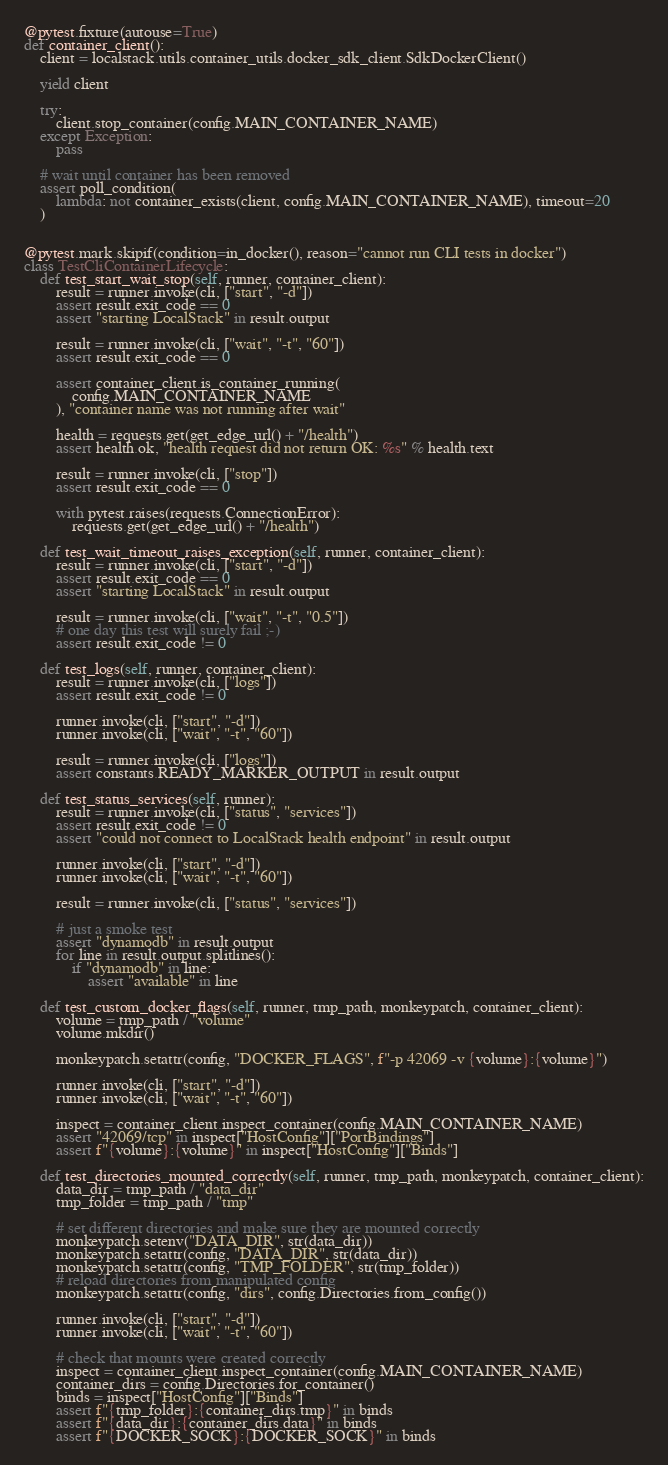Convert code to text. <code><loc_0><loc_0><loc_500><loc_500><_Python_>

@pytest.fixture(autouse=True)
def container_client():
    client = localstack.utils.container_utils.docker_sdk_client.SdkDockerClient()

    yield client

    try:
        client.stop_container(config.MAIN_CONTAINER_NAME)
    except Exception:
        pass

    # wait until container has been removed
    assert poll_condition(
        lambda: not container_exists(client, config.MAIN_CONTAINER_NAME), timeout=20
    )


@pytest.mark.skipif(condition=in_docker(), reason="cannot run CLI tests in docker")
class TestCliContainerLifecycle:
    def test_start_wait_stop(self, runner, container_client):
        result = runner.invoke(cli, ["start", "-d"])
        assert result.exit_code == 0
        assert "starting LocalStack" in result.output

        result = runner.invoke(cli, ["wait", "-t", "60"])
        assert result.exit_code == 0

        assert container_client.is_container_running(
            config.MAIN_CONTAINER_NAME
        ), "container name was not running after wait"

        health = requests.get(get_edge_url() + "/health")
        assert health.ok, "health request did not return OK: %s" % health.text

        result = runner.invoke(cli, ["stop"])
        assert result.exit_code == 0

        with pytest.raises(requests.ConnectionError):
            requests.get(get_edge_url() + "/health")

    def test_wait_timeout_raises_exception(self, runner, container_client):
        result = runner.invoke(cli, ["start", "-d"])
        assert result.exit_code == 0
        assert "starting LocalStack" in result.output

        result = runner.invoke(cli, ["wait", "-t", "0.5"])
        # one day this test will surely fail ;-)
        assert result.exit_code != 0

    def test_logs(self, runner, container_client):
        result = runner.invoke(cli, ["logs"])
        assert result.exit_code != 0

        runner.invoke(cli, ["start", "-d"])
        runner.invoke(cli, ["wait", "-t", "60"])

        result = runner.invoke(cli, ["logs"])
        assert constants.READY_MARKER_OUTPUT in result.output

    def test_status_services(self, runner):
        result = runner.invoke(cli, ["status", "services"])
        assert result.exit_code != 0
        assert "could not connect to LocalStack health endpoint" in result.output

        runner.invoke(cli, ["start", "-d"])
        runner.invoke(cli, ["wait", "-t", "60"])

        result = runner.invoke(cli, ["status", "services"])

        # just a smoke test
        assert "dynamodb" in result.output
        for line in result.output.splitlines():
            if "dynamodb" in line:
                assert "available" in line

    def test_custom_docker_flags(self, runner, tmp_path, monkeypatch, container_client):
        volume = tmp_path / "volume"
        volume.mkdir()

        monkeypatch.setattr(config, "DOCKER_FLAGS", f"-p 42069 -v {volume}:{volume}")

        runner.invoke(cli, ["start", "-d"])
        runner.invoke(cli, ["wait", "-t", "60"])

        inspect = container_client.inspect_container(config.MAIN_CONTAINER_NAME)
        assert "42069/tcp" in inspect["HostConfig"]["PortBindings"]
        assert f"{volume}:{volume}" in inspect["HostConfig"]["Binds"]

    def test_directories_mounted_correctly(self, runner, tmp_path, monkeypatch, container_client):
        data_dir = tmp_path / "data_dir"
        tmp_folder = tmp_path / "tmp"

        # set different directories and make sure they are mounted correctly
        monkeypatch.setenv("DATA_DIR", str(data_dir))
        monkeypatch.setattr(config, "DATA_DIR", str(data_dir))
        monkeypatch.setattr(config, "TMP_FOLDER", str(tmp_folder))
        # reload directories from manipulated config
        monkeypatch.setattr(config, "dirs", config.Directories.from_config())

        runner.invoke(cli, ["start", "-d"])
        runner.invoke(cli, ["wait", "-t", "60"])

        # check that mounts were created correctly
        inspect = container_client.inspect_container(config.MAIN_CONTAINER_NAME)
        container_dirs = config.Directories.for_container()
        binds = inspect["HostConfig"]["Binds"]
        assert f"{tmp_folder}:{container_dirs.tmp}" in binds
        assert f"{data_dir}:{container_dirs.data}" in binds
        assert f"{DOCKER_SOCK}:{DOCKER_SOCK}" in binds
</code> 